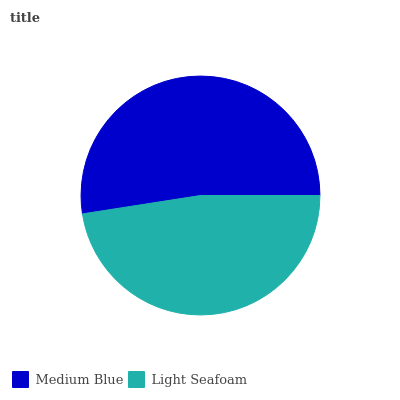Is Light Seafoam the minimum?
Answer yes or no. Yes. Is Medium Blue the maximum?
Answer yes or no. Yes. Is Light Seafoam the maximum?
Answer yes or no. No. Is Medium Blue greater than Light Seafoam?
Answer yes or no. Yes. Is Light Seafoam less than Medium Blue?
Answer yes or no. Yes. Is Light Seafoam greater than Medium Blue?
Answer yes or no. No. Is Medium Blue less than Light Seafoam?
Answer yes or no. No. Is Medium Blue the high median?
Answer yes or no. Yes. Is Light Seafoam the low median?
Answer yes or no. Yes. Is Light Seafoam the high median?
Answer yes or no. No. Is Medium Blue the low median?
Answer yes or no. No. 